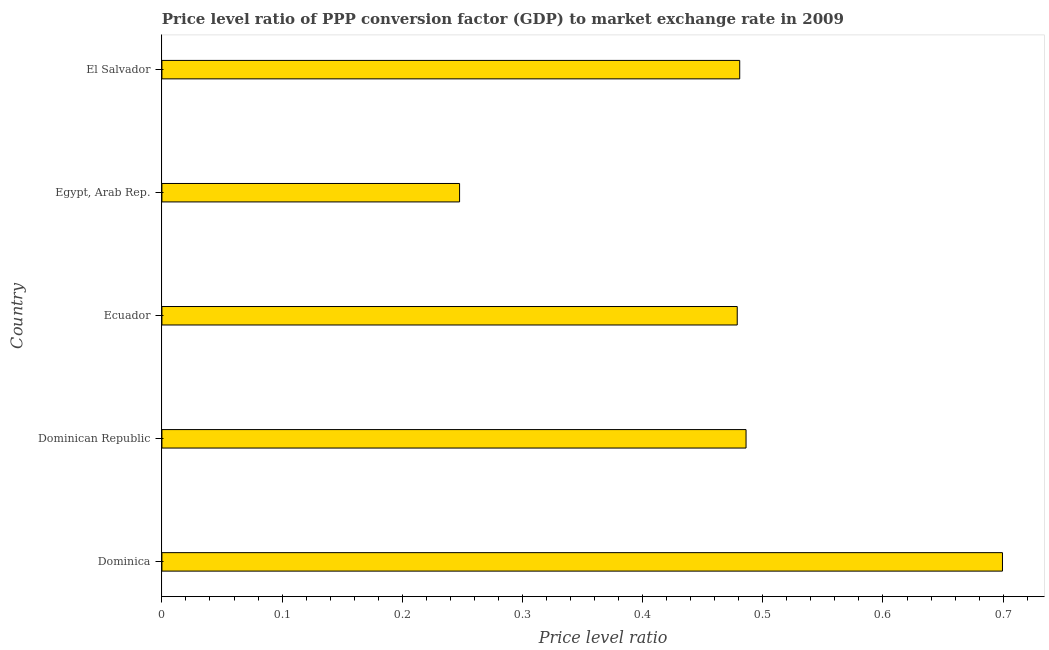Does the graph contain any zero values?
Give a very brief answer. No. Does the graph contain grids?
Make the answer very short. No. What is the title of the graph?
Make the answer very short. Price level ratio of PPP conversion factor (GDP) to market exchange rate in 2009. What is the label or title of the X-axis?
Your response must be concise. Price level ratio. What is the label or title of the Y-axis?
Your response must be concise. Country. What is the price level ratio in Dominican Republic?
Your response must be concise. 0.49. Across all countries, what is the maximum price level ratio?
Your response must be concise. 0.7. Across all countries, what is the minimum price level ratio?
Provide a short and direct response. 0.25. In which country was the price level ratio maximum?
Make the answer very short. Dominica. In which country was the price level ratio minimum?
Provide a succinct answer. Egypt, Arab Rep. What is the sum of the price level ratio?
Provide a succinct answer. 2.39. What is the difference between the price level ratio in Egypt, Arab Rep. and El Salvador?
Offer a very short reply. -0.23. What is the average price level ratio per country?
Provide a succinct answer. 0.48. What is the median price level ratio?
Ensure brevity in your answer.  0.48. In how many countries, is the price level ratio greater than 0.36 ?
Provide a succinct answer. 4. What is the ratio of the price level ratio in Dominica to that in Ecuador?
Offer a terse response. 1.46. Is the price level ratio in Dominica less than that in Ecuador?
Provide a succinct answer. No. Is the difference between the price level ratio in Ecuador and Egypt, Arab Rep. greater than the difference between any two countries?
Your answer should be compact. No. What is the difference between the highest and the second highest price level ratio?
Ensure brevity in your answer.  0.21. Is the sum of the price level ratio in Dominican Republic and El Salvador greater than the maximum price level ratio across all countries?
Keep it short and to the point. Yes. What is the difference between the highest and the lowest price level ratio?
Provide a short and direct response. 0.45. In how many countries, is the price level ratio greater than the average price level ratio taken over all countries?
Keep it short and to the point. 4. How many bars are there?
Your answer should be compact. 5. How many countries are there in the graph?
Your answer should be compact. 5. What is the difference between two consecutive major ticks on the X-axis?
Keep it short and to the point. 0.1. What is the Price level ratio in Dominica?
Give a very brief answer. 0.7. What is the Price level ratio in Dominican Republic?
Your answer should be very brief. 0.49. What is the Price level ratio of Ecuador?
Your response must be concise. 0.48. What is the Price level ratio in Egypt, Arab Rep.?
Give a very brief answer. 0.25. What is the Price level ratio of El Salvador?
Keep it short and to the point. 0.48. What is the difference between the Price level ratio in Dominica and Dominican Republic?
Make the answer very short. 0.21. What is the difference between the Price level ratio in Dominica and Ecuador?
Ensure brevity in your answer.  0.22. What is the difference between the Price level ratio in Dominica and Egypt, Arab Rep.?
Keep it short and to the point. 0.45. What is the difference between the Price level ratio in Dominica and El Salvador?
Offer a terse response. 0.22. What is the difference between the Price level ratio in Dominican Republic and Ecuador?
Offer a terse response. 0.01. What is the difference between the Price level ratio in Dominican Republic and Egypt, Arab Rep.?
Keep it short and to the point. 0.24. What is the difference between the Price level ratio in Dominican Republic and El Salvador?
Offer a terse response. 0.01. What is the difference between the Price level ratio in Ecuador and Egypt, Arab Rep.?
Ensure brevity in your answer.  0.23. What is the difference between the Price level ratio in Ecuador and El Salvador?
Your answer should be very brief. -0. What is the difference between the Price level ratio in Egypt, Arab Rep. and El Salvador?
Provide a short and direct response. -0.23. What is the ratio of the Price level ratio in Dominica to that in Dominican Republic?
Keep it short and to the point. 1.44. What is the ratio of the Price level ratio in Dominica to that in Ecuador?
Give a very brief answer. 1.46. What is the ratio of the Price level ratio in Dominica to that in Egypt, Arab Rep.?
Keep it short and to the point. 2.82. What is the ratio of the Price level ratio in Dominica to that in El Salvador?
Your answer should be very brief. 1.46. What is the ratio of the Price level ratio in Dominican Republic to that in Egypt, Arab Rep.?
Your answer should be very brief. 1.96. What is the ratio of the Price level ratio in Dominican Republic to that in El Salvador?
Provide a succinct answer. 1.01. What is the ratio of the Price level ratio in Ecuador to that in Egypt, Arab Rep.?
Your response must be concise. 1.93. What is the ratio of the Price level ratio in Egypt, Arab Rep. to that in El Salvador?
Keep it short and to the point. 0.52. 